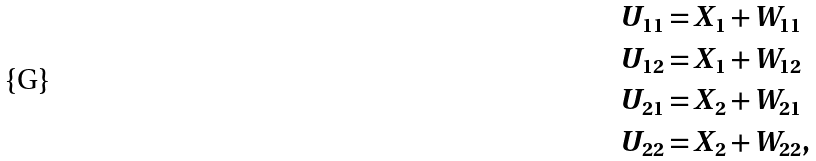Convert formula to latex. <formula><loc_0><loc_0><loc_500><loc_500>U _ { 1 1 } & = X _ { 1 } + W _ { 1 1 } \\ U _ { 1 2 } & = X _ { 1 } + W _ { 1 2 } \\ U _ { 2 1 } & = X _ { 2 } + W _ { 2 1 } \\ U _ { 2 2 } & = X _ { 2 } + W _ { 2 2 } ,</formula> 